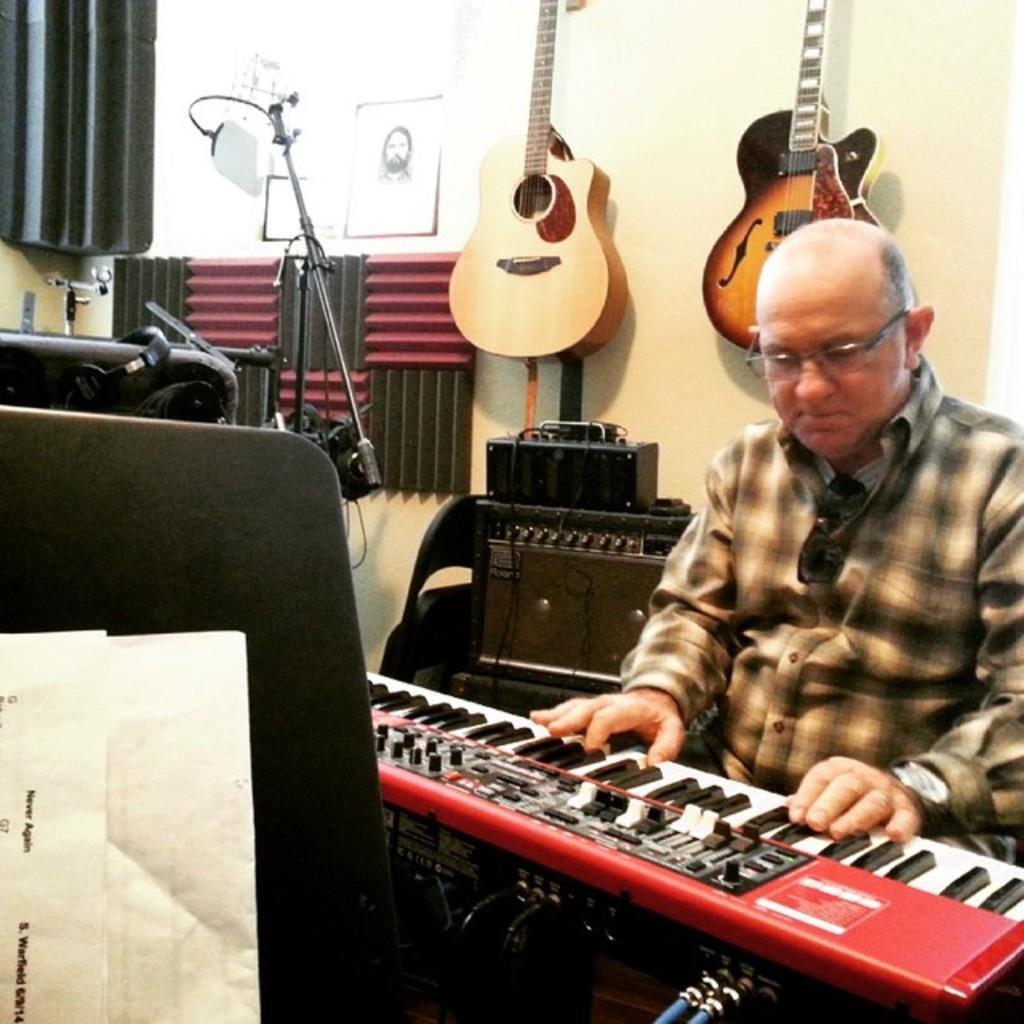Can you describe this image briefly? In this image i can see a man sitting and playing piano at the back ground i can see few other musical instruments and a wall. 